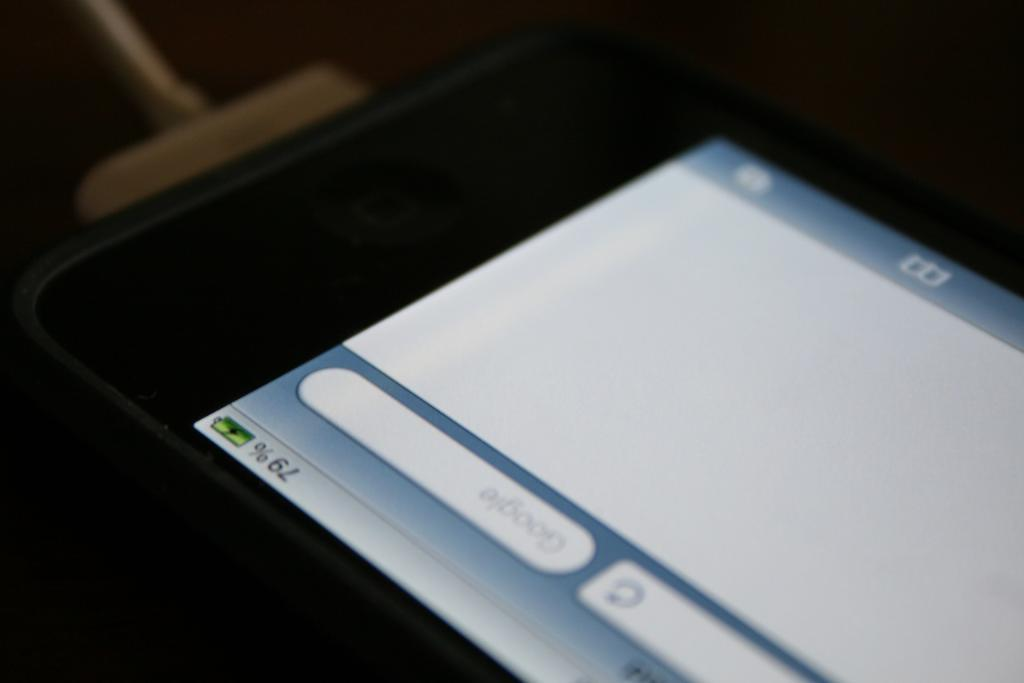Provide a one-sentence caption for the provided image. A black iPhone is charging and at 79 percent battery. 